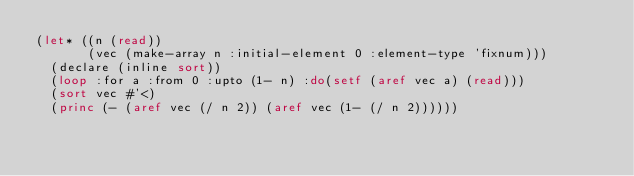Convert code to text. <code><loc_0><loc_0><loc_500><loc_500><_Lisp_>(let* ((n (read))
       (vec (make-array n :initial-element 0 :element-type 'fixnum)))
  (declare (inline sort))
  (loop :for a :from 0 :upto (1- n) :do(setf (aref vec a) (read)))
  (sort vec #'<)
  (princ (- (aref vec (/ n 2)) (aref vec (1- (/ n 2))))))</code> 